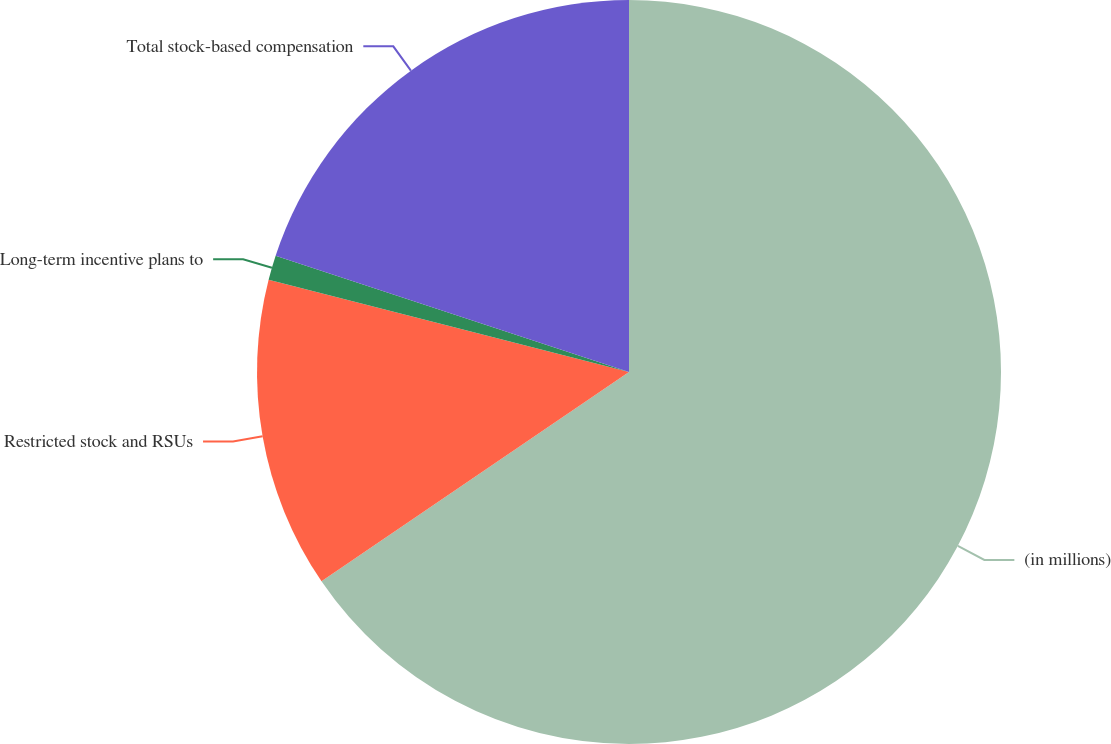Convert chart. <chart><loc_0><loc_0><loc_500><loc_500><pie_chart><fcel>(in millions)<fcel>Restricted stock and RSUs<fcel>Long-term incentive plans to<fcel>Total stock-based compensation<nl><fcel>65.48%<fcel>13.5%<fcel>1.07%<fcel>19.94%<nl></chart> 